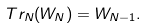<formula> <loc_0><loc_0><loc_500><loc_500>T r _ { N } ( W _ { N } ) = W _ { N - 1 } .</formula> 